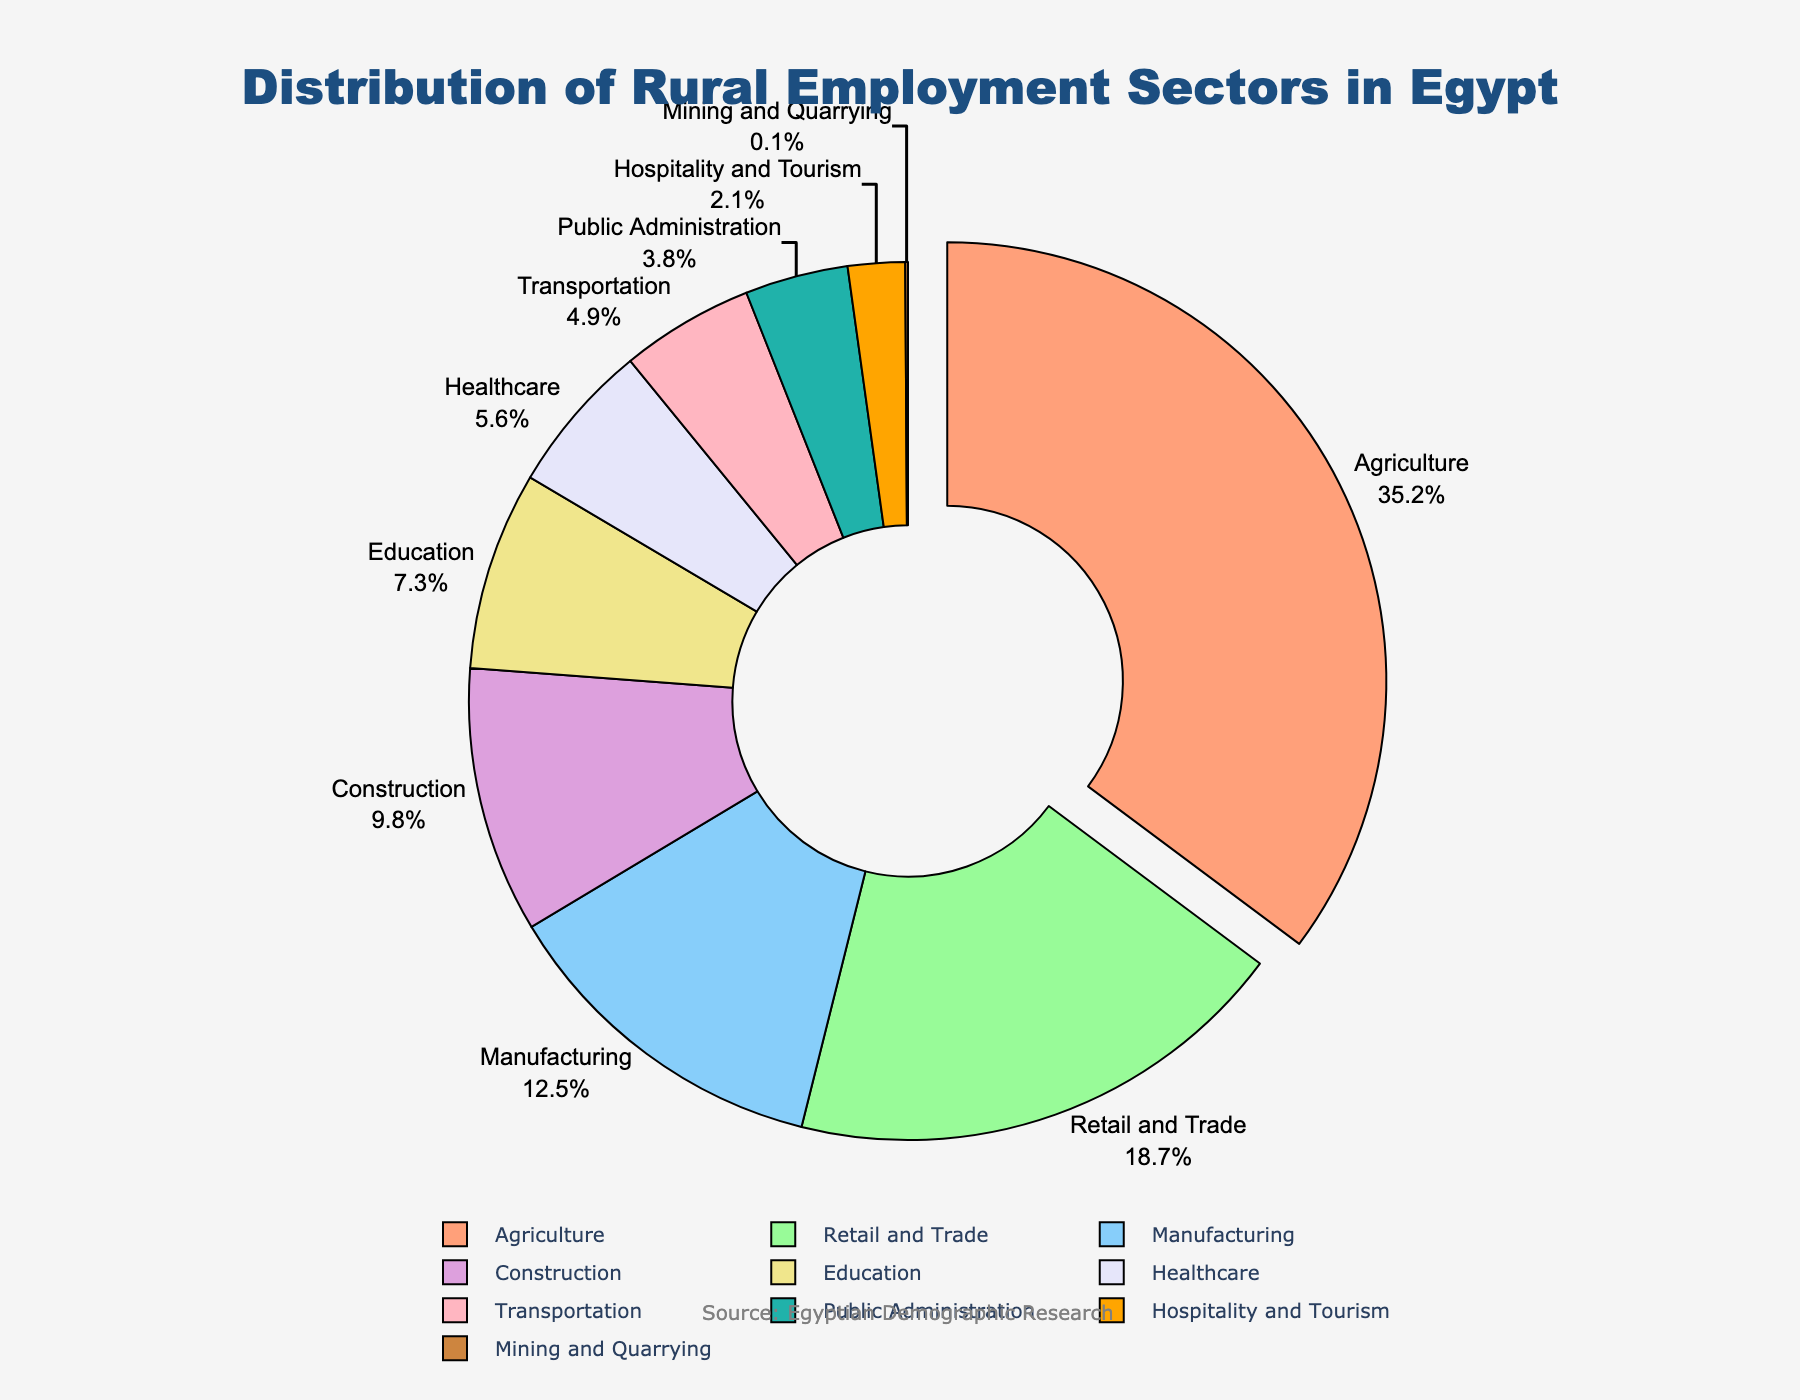What is the largest employment sector? The largest sector is the one with the highest percentage. From the figure, Agriculture has the highest percentage of 35.2%.
Answer: Agriculture What percentage of rural employment is in Education and Healthcare combined? Add the percentages of Education (7.3%) and Healthcare (5.6%). 7.3% + 5.6% = 12.9%
Answer: 12.9% Which sector has a lower percentage of employment, Manufacturing or Construction? The figure shows Manufacturing at 12.5% and Construction at 9.8%. Since 9.8% is lower than 12.5%, Construction has a lower percentage.
Answer: Construction Are there more people employed in Retail and Trade or in Education and Public Administration combined? Check Retail and Trade (18.7%) against the sum of Education (7.3%) and Public Administration (3.8%). 7.3% + 3.8% = 11.1%, which is less than 18.7%.
Answer: Retail and Trade What sector has the smallest employment percentage? The smallest sector is the one with the lowest percentage. From the figure, Mining and Quarrying has the smallest percentage of 0.1%.
Answer: Mining and Quarrying By how much does the percentage of employment in Agriculture exceed that in Manufacturing? Subtract the percentage of Manufacturing (12.5%) from Agriculture (35.2%). 35.2% - 12.5% = 22.7%
Answer: 22.7% Which color is used to represent the Healthcare sector on the pie chart? The Healthcare sector is represented in a light purple shade.
Answer: Light purple How much larger is the percentage of employment in Agriculture compared to the combined percentage in Construction and Hospitality and Tourism? Add the percentages of Construction (9.8%) and Hospitality and Tourism (2.1%). 9.8% + 2.1% = 11.9%. Then, subtract this from Agriculture (35.2%). 35.2% - 11.9% = 23.3%
Answer: 23.3% What is the combined percentage of sectors with less than 5% employment? Add the percentages of Transportation (4.9%), Public Administration (3.8%), Hospitality and Tourism (2.1%), and Mining and Quarrying (0.1%). 4.9% + 3.8% + 2.1% + 0.1% = 10.9%
Answer: 10.9% Does the Retail and Trade sector employ more than three times the number of people in Mining and Quarrying? Calculate three times the Mining and Quarrying percentage: 3 * 0.1% = 0.3%. Compare with Retail and Trade (18.7%), which is significantly higher than 0.3%. Hence, it employs more than three times the people in Mining and Quarrying.
Answer: Yes 